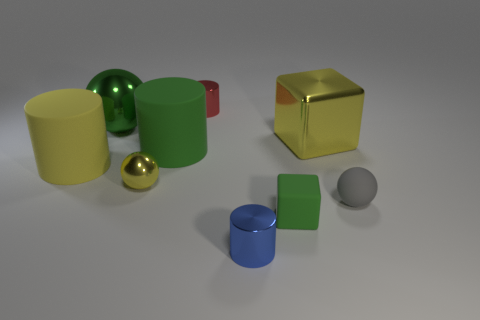Subtract all blue shiny cylinders. How many cylinders are left? 3 Add 1 small matte things. How many objects exist? 10 Subtract all yellow blocks. How many blocks are left? 1 Subtract all cylinders. How many objects are left? 5 Subtract 1 cubes. How many cubes are left? 1 Subtract all purple cubes. How many red cylinders are left? 1 Add 6 large cubes. How many large cubes exist? 7 Subtract 0 cyan balls. How many objects are left? 9 Subtract all brown balls. Subtract all green cylinders. How many balls are left? 3 Subtract all yellow metallic objects. Subtract all big things. How many objects are left? 3 